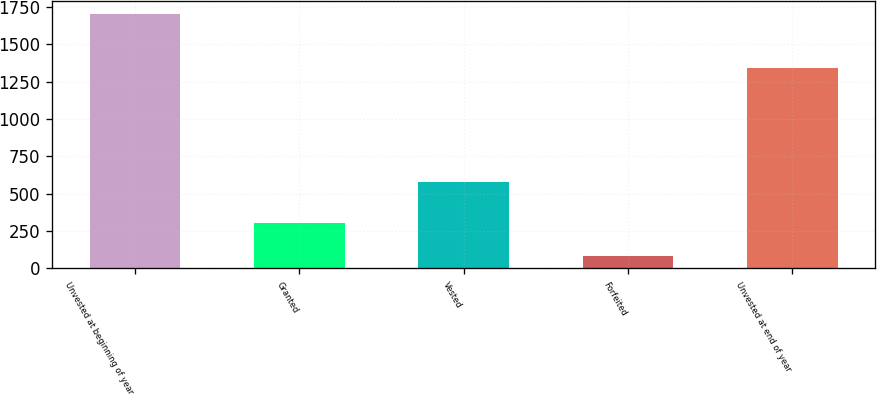Convert chart. <chart><loc_0><loc_0><loc_500><loc_500><bar_chart><fcel>Unvested at beginning of year<fcel>Granted<fcel>Vested<fcel>Forfeited<fcel>Unvested at end of year<nl><fcel>1701<fcel>304<fcel>580<fcel>82<fcel>1343<nl></chart> 